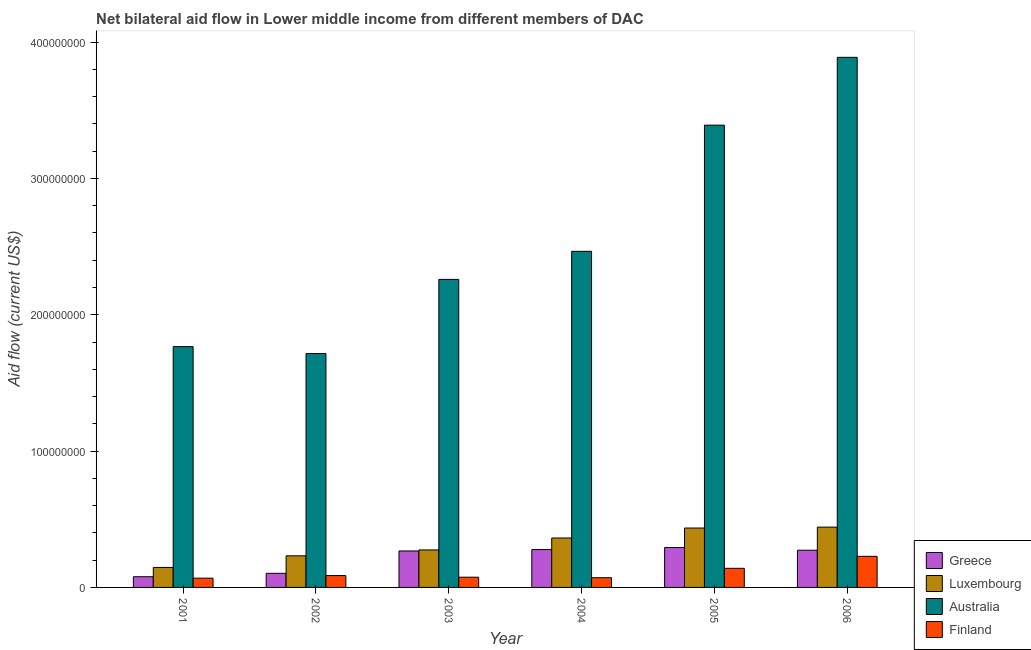How many different coloured bars are there?
Give a very brief answer. 4. How many groups of bars are there?
Your answer should be compact. 6. Are the number of bars on each tick of the X-axis equal?
Keep it short and to the point. Yes. What is the label of the 6th group of bars from the left?
Provide a succinct answer. 2006. What is the amount of aid given by luxembourg in 2002?
Your answer should be compact. 2.32e+07. Across all years, what is the maximum amount of aid given by australia?
Give a very brief answer. 3.89e+08. Across all years, what is the minimum amount of aid given by australia?
Ensure brevity in your answer.  1.72e+08. In which year was the amount of aid given by greece maximum?
Make the answer very short. 2005. What is the total amount of aid given by luxembourg in the graph?
Your response must be concise. 1.89e+08. What is the difference between the amount of aid given by australia in 2003 and that in 2004?
Your answer should be very brief. -2.06e+07. What is the difference between the amount of aid given by greece in 2004 and the amount of aid given by luxembourg in 2002?
Offer a very short reply. 1.74e+07. What is the average amount of aid given by finland per year?
Your answer should be compact. 1.12e+07. In the year 2005, what is the difference between the amount of aid given by finland and amount of aid given by greece?
Provide a short and direct response. 0. What is the ratio of the amount of aid given by luxembourg in 2004 to that in 2005?
Make the answer very short. 0.83. Is the amount of aid given by australia in 2002 less than that in 2004?
Provide a succinct answer. Yes. What is the difference between the highest and the second highest amount of aid given by luxembourg?
Your answer should be compact. 6.70e+05. What is the difference between the highest and the lowest amount of aid given by luxembourg?
Your response must be concise. 2.96e+07. In how many years, is the amount of aid given by luxembourg greater than the average amount of aid given by luxembourg taken over all years?
Your response must be concise. 3. Is the sum of the amount of aid given by finland in 2001 and 2004 greater than the maximum amount of aid given by greece across all years?
Your answer should be very brief. No. What does the 4th bar from the right in 2005 represents?
Provide a succinct answer. Greece. Are all the bars in the graph horizontal?
Provide a succinct answer. No. How many years are there in the graph?
Offer a terse response. 6. What is the difference between two consecutive major ticks on the Y-axis?
Your answer should be compact. 1.00e+08. Does the graph contain grids?
Ensure brevity in your answer.  No. What is the title of the graph?
Provide a short and direct response. Net bilateral aid flow in Lower middle income from different members of DAC. Does "Australia" appear as one of the legend labels in the graph?
Your answer should be very brief. Yes. What is the Aid flow (current US$) in Greece in 2001?
Offer a terse response. 7.85e+06. What is the Aid flow (current US$) in Luxembourg in 2001?
Offer a terse response. 1.47e+07. What is the Aid flow (current US$) in Australia in 2001?
Your answer should be compact. 1.77e+08. What is the Aid flow (current US$) in Finland in 2001?
Provide a succinct answer. 6.79e+06. What is the Aid flow (current US$) in Greece in 2002?
Provide a succinct answer. 1.04e+07. What is the Aid flow (current US$) in Luxembourg in 2002?
Your response must be concise. 2.32e+07. What is the Aid flow (current US$) in Australia in 2002?
Your answer should be very brief. 1.72e+08. What is the Aid flow (current US$) in Finland in 2002?
Keep it short and to the point. 8.70e+06. What is the Aid flow (current US$) in Greece in 2003?
Provide a succinct answer. 2.68e+07. What is the Aid flow (current US$) of Luxembourg in 2003?
Provide a short and direct response. 2.75e+07. What is the Aid flow (current US$) of Australia in 2003?
Offer a terse response. 2.26e+08. What is the Aid flow (current US$) in Finland in 2003?
Keep it short and to the point. 7.50e+06. What is the Aid flow (current US$) in Greece in 2004?
Ensure brevity in your answer.  2.78e+07. What is the Aid flow (current US$) of Luxembourg in 2004?
Your response must be concise. 3.63e+07. What is the Aid flow (current US$) in Australia in 2004?
Offer a terse response. 2.47e+08. What is the Aid flow (current US$) in Finland in 2004?
Provide a succinct answer. 7.13e+06. What is the Aid flow (current US$) of Greece in 2005?
Make the answer very short. 2.93e+07. What is the Aid flow (current US$) of Luxembourg in 2005?
Provide a short and direct response. 4.36e+07. What is the Aid flow (current US$) of Australia in 2005?
Make the answer very short. 3.39e+08. What is the Aid flow (current US$) of Finland in 2005?
Offer a very short reply. 1.40e+07. What is the Aid flow (current US$) of Greece in 2006?
Provide a short and direct response. 2.73e+07. What is the Aid flow (current US$) in Luxembourg in 2006?
Your answer should be compact. 4.42e+07. What is the Aid flow (current US$) in Australia in 2006?
Offer a terse response. 3.89e+08. What is the Aid flow (current US$) in Finland in 2006?
Provide a short and direct response. 2.28e+07. Across all years, what is the maximum Aid flow (current US$) in Greece?
Ensure brevity in your answer.  2.93e+07. Across all years, what is the maximum Aid flow (current US$) of Luxembourg?
Provide a short and direct response. 4.42e+07. Across all years, what is the maximum Aid flow (current US$) in Australia?
Make the answer very short. 3.89e+08. Across all years, what is the maximum Aid flow (current US$) in Finland?
Make the answer very short. 2.28e+07. Across all years, what is the minimum Aid flow (current US$) in Greece?
Your answer should be compact. 7.85e+06. Across all years, what is the minimum Aid flow (current US$) in Luxembourg?
Provide a succinct answer. 1.47e+07. Across all years, what is the minimum Aid flow (current US$) in Australia?
Ensure brevity in your answer.  1.72e+08. Across all years, what is the minimum Aid flow (current US$) in Finland?
Provide a short and direct response. 6.79e+06. What is the total Aid flow (current US$) of Greece in the graph?
Offer a very short reply. 1.29e+08. What is the total Aid flow (current US$) in Luxembourg in the graph?
Make the answer very short. 1.89e+08. What is the total Aid flow (current US$) in Australia in the graph?
Offer a terse response. 1.55e+09. What is the total Aid flow (current US$) of Finland in the graph?
Your answer should be very brief. 6.69e+07. What is the difference between the Aid flow (current US$) in Greece in 2001 and that in 2002?
Ensure brevity in your answer.  -2.50e+06. What is the difference between the Aid flow (current US$) in Luxembourg in 2001 and that in 2002?
Provide a short and direct response. -8.52e+06. What is the difference between the Aid flow (current US$) in Australia in 2001 and that in 2002?
Your answer should be very brief. 5.09e+06. What is the difference between the Aid flow (current US$) in Finland in 2001 and that in 2002?
Your answer should be very brief. -1.91e+06. What is the difference between the Aid flow (current US$) in Greece in 2001 and that in 2003?
Provide a short and direct response. -1.89e+07. What is the difference between the Aid flow (current US$) in Luxembourg in 2001 and that in 2003?
Offer a terse response. -1.28e+07. What is the difference between the Aid flow (current US$) of Australia in 2001 and that in 2003?
Ensure brevity in your answer.  -4.93e+07. What is the difference between the Aid flow (current US$) in Finland in 2001 and that in 2003?
Provide a short and direct response. -7.10e+05. What is the difference between the Aid flow (current US$) in Greece in 2001 and that in 2004?
Your response must be concise. -1.99e+07. What is the difference between the Aid flow (current US$) of Luxembourg in 2001 and that in 2004?
Provide a short and direct response. -2.16e+07. What is the difference between the Aid flow (current US$) of Australia in 2001 and that in 2004?
Your response must be concise. -6.99e+07. What is the difference between the Aid flow (current US$) in Finland in 2001 and that in 2004?
Keep it short and to the point. -3.40e+05. What is the difference between the Aid flow (current US$) of Greece in 2001 and that in 2005?
Make the answer very short. -2.14e+07. What is the difference between the Aid flow (current US$) of Luxembourg in 2001 and that in 2005?
Your answer should be very brief. -2.89e+07. What is the difference between the Aid flow (current US$) of Australia in 2001 and that in 2005?
Give a very brief answer. -1.62e+08. What is the difference between the Aid flow (current US$) of Finland in 2001 and that in 2005?
Offer a terse response. -7.22e+06. What is the difference between the Aid flow (current US$) in Greece in 2001 and that in 2006?
Your response must be concise. -1.94e+07. What is the difference between the Aid flow (current US$) of Luxembourg in 2001 and that in 2006?
Give a very brief answer. -2.96e+07. What is the difference between the Aid flow (current US$) in Australia in 2001 and that in 2006?
Your answer should be compact. -2.12e+08. What is the difference between the Aid flow (current US$) in Finland in 2001 and that in 2006?
Ensure brevity in your answer.  -1.60e+07. What is the difference between the Aid flow (current US$) of Greece in 2002 and that in 2003?
Offer a very short reply. -1.64e+07. What is the difference between the Aid flow (current US$) in Luxembourg in 2002 and that in 2003?
Your response must be concise. -4.33e+06. What is the difference between the Aid flow (current US$) in Australia in 2002 and that in 2003?
Offer a very short reply. -5.44e+07. What is the difference between the Aid flow (current US$) of Finland in 2002 and that in 2003?
Provide a short and direct response. 1.20e+06. What is the difference between the Aid flow (current US$) of Greece in 2002 and that in 2004?
Ensure brevity in your answer.  -1.74e+07. What is the difference between the Aid flow (current US$) of Luxembourg in 2002 and that in 2004?
Ensure brevity in your answer.  -1.31e+07. What is the difference between the Aid flow (current US$) in Australia in 2002 and that in 2004?
Provide a succinct answer. -7.50e+07. What is the difference between the Aid flow (current US$) in Finland in 2002 and that in 2004?
Give a very brief answer. 1.57e+06. What is the difference between the Aid flow (current US$) of Greece in 2002 and that in 2005?
Offer a terse response. -1.89e+07. What is the difference between the Aid flow (current US$) in Luxembourg in 2002 and that in 2005?
Provide a succinct answer. -2.04e+07. What is the difference between the Aid flow (current US$) in Australia in 2002 and that in 2005?
Provide a succinct answer. -1.68e+08. What is the difference between the Aid flow (current US$) of Finland in 2002 and that in 2005?
Your response must be concise. -5.31e+06. What is the difference between the Aid flow (current US$) in Greece in 2002 and that in 2006?
Make the answer very short. -1.69e+07. What is the difference between the Aid flow (current US$) of Luxembourg in 2002 and that in 2006?
Offer a terse response. -2.11e+07. What is the difference between the Aid flow (current US$) in Australia in 2002 and that in 2006?
Your answer should be very brief. -2.17e+08. What is the difference between the Aid flow (current US$) in Finland in 2002 and that in 2006?
Give a very brief answer. -1.41e+07. What is the difference between the Aid flow (current US$) in Greece in 2003 and that in 2004?
Provide a short and direct response. -1.03e+06. What is the difference between the Aid flow (current US$) in Luxembourg in 2003 and that in 2004?
Ensure brevity in your answer.  -8.75e+06. What is the difference between the Aid flow (current US$) of Australia in 2003 and that in 2004?
Provide a short and direct response. -2.06e+07. What is the difference between the Aid flow (current US$) of Finland in 2003 and that in 2004?
Your answer should be compact. 3.70e+05. What is the difference between the Aid flow (current US$) of Greece in 2003 and that in 2005?
Offer a very short reply. -2.51e+06. What is the difference between the Aid flow (current US$) of Luxembourg in 2003 and that in 2005?
Provide a succinct answer. -1.61e+07. What is the difference between the Aid flow (current US$) of Australia in 2003 and that in 2005?
Provide a short and direct response. -1.13e+08. What is the difference between the Aid flow (current US$) in Finland in 2003 and that in 2005?
Give a very brief answer. -6.51e+06. What is the difference between the Aid flow (current US$) of Greece in 2003 and that in 2006?
Your answer should be compact. -5.20e+05. What is the difference between the Aid flow (current US$) of Luxembourg in 2003 and that in 2006?
Provide a short and direct response. -1.67e+07. What is the difference between the Aid flow (current US$) of Australia in 2003 and that in 2006?
Keep it short and to the point. -1.63e+08. What is the difference between the Aid flow (current US$) of Finland in 2003 and that in 2006?
Ensure brevity in your answer.  -1.53e+07. What is the difference between the Aid flow (current US$) in Greece in 2004 and that in 2005?
Your answer should be compact. -1.48e+06. What is the difference between the Aid flow (current US$) in Luxembourg in 2004 and that in 2005?
Keep it short and to the point. -7.31e+06. What is the difference between the Aid flow (current US$) in Australia in 2004 and that in 2005?
Ensure brevity in your answer.  -9.26e+07. What is the difference between the Aid flow (current US$) of Finland in 2004 and that in 2005?
Provide a short and direct response. -6.88e+06. What is the difference between the Aid flow (current US$) of Greece in 2004 and that in 2006?
Your response must be concise. 5.10e+05. What is the difference between the Aid flow (current US$) of Luxembourg in 2004 and that in 2006?
Provide a short and direct response. -7.98e+06. What is the difference between the Aid flow (current US$) in Australia in 2004 and that in 2006?
Give a very brief answer. -1.42e+08. What is the difference between the Aid flow (current US$) in Finland in 2004 and that in 2006?
Offer a very short reply. -1.57e+07. What is the difference between the Aid flow (current US$) in Greece in 2005 and that in 2006?
Your answer should be very brief. 1.99e+06. What is the difference between the Aid flow (current US$) of Luxembourg in 2005 and that in 2006?
Offer a terse response. -6.70e+05. What is the difference between the Aid flow (current US$) of Australia in 2005 and that in 2006?
Your answer should be compact. -4.97e+07. What is the difference between the Aid flow (current US$) in Finland in 2005 and that in 2006?
Give a very brief answer. -8.80e+06. What is the difference between the Aid flow (current US$) of Greece in 2001 and the Aid flow (current US$) of Luxembourg in 2002?
Your answer should be very brief. -1.53e+07. What is the difference between the Aid flow (current US$) of Greece in 2001 and the Aid flow (current US$) of Australia in 2002?
Offer a terse response. -1.64e+08. What is the difference between the Aid flow (current US$) in Greece in 2001 and the Aid flow (current US$) in Finland in 2002?
Keep it short and to the point. -8.50e+05. What is the difference between the Aid flow (current US$) of Luxembourg in 2001 and the Aid flow (current US$) of Australia in 2002?
Make the answer very short. -1.57e+08. What is the difference between the Aid flow (current US$) in Luxembourg in 2001 and the Aid flow (current US$) in Finland in 2002?
Your response must be concise. 5.96e+06. What is the difference between the Aid flow (current US$) of Australia in 2001 and the Aid flow (current US$) of Finland in 2002?
Offer a very short reply. 1.68e+08. What is the difference between the Aid flow (current US$) in Greece in 2001 and the Aid flow (current US$) in Luxembourg in 2003?
Keep it short and to the point. -1.97e+07. What is the difference between the Aid flow (current US$) of Greece in 2001 and the Aid flow (current US$) of Australia in 2003?
Ensure brevity in your answer.  -2.18e+08. What is the difference between the Aid flow (current US$) of Luxembourg in 2001 and the Aid flow (current US$) of Australia in 2003?
Ensure brevity in your answer.  -2.11e+08. What is the difference between the Aid flow (current US$) in Luxembourg in 2001 and the Aid flow (current US$) in Finland in 2003?
Your answer should be compact. 7.16e+06. What is the difference between the Aid flow (current US$) in Australia in 2001 and the Aid flow (current US$) in Finland in 2003?
Your answer should be very brief. 1.69e+08. What is the difference between the Aid flow (current US$) in Greece in 2001 and the Aid flow (current US$) in Luxembourg in 2004?
Ensure brevity in your answer.  -2.84e+07. What is the difference between the Aid flow (current US$) of Greece in 2001 and the Aid flow (current US$) of Australia in 2004?
Your answer should be very brief. -2.39e+08. What is the difference between the Aid flow (current US$) of Greece in 2001 and the Aid flow (current US$) of Finland in 2004?
Your answer should be compact. 7.20e+05. What is the difference between the Aid flow (current US$) in Luxembourg in 2001 and the Aid flow (current US$) in Australia in 2004?
Your answer should be compact. -2.32e+08. What is the difference between the Aid flow (current US$) in Luxembourg in 2001 and the Aid flow (current US$) in Finland in 2004?
Your answer should be very brief. 7.53e+06. What is the difference between the Aid flow (current US$) of Australia in 2001 and the Aid flow (current US$) of Finland in 2004?
Offer a very short reply. 1.70e+08. What is the difference between the Aid flow (current US$) in Greece in 2001 and the Aid flow (current US$) in Luxembourg in 2005?
Make the answer very short. -3.57e+07. What is the difference between the Aid flow (current US$) of Greece in 2001 and the Aid flow (current US$) of Australia in 2005?
Keep it short and to the point. -3.31e+08. What is the difference between the Aid flow (current US$) in Greece in 2001 and the Aid flow (current US$) in Finland in 2005?
Offer a very short reply. -6.16e+06. What is the difference between the Aid flow (current US$) of Luxembourg in 2001 and the Aid flow (current US$) of Australia in 2005?
Provide a short and direct response. -3.24e+08. What is the difference between the Aid flow (current US$) in Luxembourg in 2001 and the Aid flow (current US$) in Finland in 2005?
Your answer should be very brief. 6.50e+05. What is the difference between the Aid flow (current US$) of Australia in 2001 and the Aid flow (current US$) of Finland in 2005?
Make the answer very short. 1.63e+08. What is the difference between the Aid flow (current US$) of Greece in 2001 and the Aid flow (current US$) of Luxembourg in 2006?
Make the answer very short. -3.64e+07. What is the difference between the Aid flow (current US$) of Greece in 2001 and the Aid flow (current US$) of Australia in 2006?
Keep it short and to the point. -3.81e+08. What is the difference between the Aid flow (current US$) in Greece in 2001 and the Aid flow (current US$) in Finland in 2006?
Offer a terse response. -1.50e+07. What is the difference between the Aid flow (current US$) in Luxembourg in 2001 and the Aid flow (current US$) in Australia in 2006?
Offer a very short reply. -3.74e+08. What is the difference between the Aid flow (current US$) of Luxembourg in 2001 and the Aid flow (current US$) of Finland in 2006?
Ensure brevity in your answer.  -8.15e+06. What is the difference between the Aid flow (current US$) in Australia in 2001 and the Aid flow (current US$) in Finland in 2006?
Make the answer very short. 1.54e+08. What is the difference between the Aid flow (current US$) in Greece in 2002 and the Aid flow (current US$) in Luxembourg in 2003?
Ensure brevity in your answer.  -1.72e+07. What is the difference between the Aid flow (current US$) of Greece in 2002 and the Aid flow (current US$) of Australia in 2003?
Make the answer very short. -2.16e+08. What is the difference between the Aid flow (current US$) of Greece in 2002 and the Aid flow (current US$) of Finland in 2003?
Your response must be concise. 2.85e+06. What is the difference between the Aid flow (current US$) of Luxembourg in 2002 and the Aid flow (current US$) of Australia in 2003?
Make the answer very short. -2.03e+08. What is the difference between the Aid flow (current US$) in Luxembourg in 2002 and the Aid flow (current US$) in Finland in 2003?
Your answer should be very brief. 1.57e+07. What is the difference between the Aid flow (current US$) of Australia in 2002 and the Aid flow (current US$) of Finland in 2003?
Your response must be concise. 1.64e+08. What is the difference between the Aid flow (current US$) in Greece in 2002 and the Aid flow (current US$) in Luxembourg in 2004?
Your response must be concise. -2.59e+07. What is the difference between the Aid flow (current US$) of Greece in 2002 and the Aid flow (current US$) of Australia in 2004?
Your answer should be compact. -2.36e+08. What is the difference between the Aid flow (current US$) of Greece in 2002 and the Aid flow (current US$) of Finland in 2004?
Keep it short and to the point. 3.22e+06. What is the difference between the Aid flow (current US$) in Luxembourg in 2002 and the Aid flow (current US$) in Australia in 2004?
Provide a short and direct response. -2.23e+08. What is the difference between the Aid flow (current US$) in Luxembourg in 2002 and the Aid flow (current US$) in Finland in 2004?
Ensure brevity in your answer.  1.60e+07. What is the difference between the Aid flow (current US$) in Australia in 2002 and the Aid flow (current US$) in Finland in 2004?
Ensure brevity in your answer.  1.64e+08. What is the difference between the Aid flow (current US$) in Greece in 2002 and the Aid flow (current US$) in Luxembourg in 2005?
Provide a succinct answer. -3.32e+07. What is the difference between the Aid flow (current US$) in Greece in 2002 and the Aid flow (current US$) in Australia in 2005?
Provide a short and direct response. -3.29e+08. What is the difference between the Aid flow (current US$) of Greece in 2002 and the Aid flow (current US$) of Finland in 2005?
Make the answer very short. -3.66e+06. What is the difference between the Aid flow (current US$) of Luxembourg in 2002 and the Aid flow (current US$) of Australia in 2005?
Give a very brief answer. -3.16e+08. What is the difference between the Aid flow (current US$) of Luxembourg in 2002 and the Aid flow (current US$) of Finland in 2005?
Keep it short and to the point. 9.17e+06. What is the difference between the Aid flow (current US$) in Australia in 2002 and the Aid flow (current US$) in Finland in 2005?
Ensure brevity in your answer.  1.58e+08. What is the difference between the Aid flow (current US$) of Greece in 2002 and the Aid flow (current US$) of Luxembourg in 2006?
Offer a terse response. -3.39e+07. What is the difference between the Aid flow (current US$) of Greece in 2002 and the Aid flow (current US$) of Australia in 2006?
Make the answer very short. -3.78e+08. What is the difference between the Aid flow (current US$) in Greece in 2002 and the Aid flow (current US$) in Finland in 2006?
Your response must be concise. -1.25e+07. What is the difference between the Aid flow (current US$) in Luxembourg in 2002 and the Aid flow (current US$) in Australia in 2006?
Offer a very short reply. -3.66e+08. What is the difference between the Aid flow (current US$) in Luxembourg in 2002 and the Aid flow (current US$) in Finland in 2006?
Offer a terse response. 3.70e+05. What is the difference between the Aid flow (current US$) in Australia in 2002 and the Aid flow (current US$) in Finland in 2006?
Your answer should be compact. 1.49e+08. What is the difference between the Aid flow (current US$) of Greece in 2003 and the Aid flow (current US$) of Luxembourg in 2004?
Keep it short and to the point. -9.51e+06. What is the difference between the Aid flow (current US$) of Greece in 2003 and the Aid flow (current US$) of Australia in 2004?
Offer a terse response. -2.20e+08. What is the difference between the Aid flow (current US$) of Greece in 2003 and the Aid flow (current US$) of Finland in 2004?
Make the answer very short. 1.96e+07. What is the difference between the Aid flow (current US$) in Luxembourg in 2003 and the Aid flow (current US$) in Australia in 2004?
Offer a terse response. -2.19e+08. What is the difference between the Aid flow (current US$) in Luxembourg in 2003 and the Aid flow (current US$) in Finland in 2004?
Your answer should be very brief. 2.04e+07. What is the difference between the Aid flow (current US$) of Australia in 2003 and the Aid flow (current US$) of Finland in 2004?
Provide a short and direct response. 2.19e+08. What is the difference between the Aid flow (current US$) in Greece in 2003 and the Aid flow (current US$) in Luxembourg in 2005?
Make the answer very short. -1.68e+07. What is the difference between the Aid flow (current US$) in Greece in 2003 and the Aid flow (current US$) in Australia in 2005?
Your answer should be very brief. -3.12e+08. What is the difference between the Aid flow (current US$) in Greece in 2003 and the Aid flow (current US$) in Finland in 2005?
Ensure brevity in your answer.  1.27e+07. What is the difference between the Aid flow (current US$) in Luxembourg in 2003 and the Aid flow (current US$) in Australia in 2005?
Provide a succinct answer. -3.12e+08. What is the difference between the Aid flow (current US$) of Luxembourg in 2003 and the Aid flow (current US$) of Finland in 2005?
Keep it short and to the point. 1.35e+07. What is the difference between the Aid flow (current US$) of Australia in 2003 and the Aid flow (current US$) of Finland in 2005?
Your response must be concise. 2.12e+08. What is the difference between the Aid flow (current US$) in Greece in 2003 and the Aid flow (current US$) in Luxembourg in 2006?
Offer a very short reply. -1.75e+07. What is the difference between the Aid flow (current US$) of Greece in 2003 and the Aid flow (current US$) of Australia in 2006?
Give a very brief answer. -3.62e+08. What is the difference between the Aid flow (current US$) in Greece in 2003 and the Aid flow (current US$) in Finland in 2006?
Ensure brevity in your answer.  3.94e+06. What is the difference between the Aid flow (current US$) in Luxembourg in 2003 and the Aid flow (current US$) in Australia in 2006?
Keep it short and to the point. -3.61e+08. What is the difference between the Aid flow (current US$) of Luxembourg in 2003 and the Aid flow (current US$) of Finland in 2006?
Keep it short and to the point. 4.70e+06. What is the difference between the Aid flow (current US$) in Australia in 2003 and the Aid flow (current US$) in Finland in 2006?
Your response must be concise. 2.03e+08. What is the difference between the Aid flow (current US$) in Greece in 2004 and the Aid flow (current US$) in Luxembourg in 2005?
Your response must be concise. -1.58e+07. What is the difference between the Aid flow (current US$) of Greece in 2004 and the Aid flow (current US$) of Australia in 2005?
Give a very brief answer. -3.11e+08. What is the difference between the Aid flow (current US$) of Greece in 2004 and the Aid flow (current US$) of Finland in 2005?
Offer a very short reply. 1.38e+07. What is the difference between the Aid flow (current US$) of Luxembourg in 2004 and the Aid flow (current US$) of Australia in 2005?
Offer a very short reply. -3.03e+08. What is the difference between the Aid flow (current US$) in Luxembourg in 2004 and the Aid flow (current US$) in Finland in 2005?
Offer a terse response. 2.22e+07. What is the difference between the Aid flow (current US$) in Australia in 2004 and the Aid flow (current US$) in Finland in 2005?
Offer a terse response. 2.33e+08. What is the difference between the Aid flow (current US$) in Greece in 2004 and the Aid flow (current US$) in Luxembourg in 2006?
Your answer should be very brief. -1.65e+07. What is the difference between the Aid flow (current US$) of Greece in 2004 and the Aid flow (current US$) of Australia in 2006?
Give a very brief answer. -3.61e+08. What is the difference between the Aid flow (current US$) in Greece in 2004 and the Aid flow (current US$) in Finland in 2006?
Ensure brevity in your answer.  4.97e+06. What is the difference between the Aid flow (current US$) in Luxembourg in 2004 and the Aid flow (current US$) in Australia in 2006?
Give a very brief answer. -3.53e+08. What is the difference between the Aid flow (current US$) of Luxembourg in 2004 and the Aid flow (current US$) of Finland in 2006?
Give a very brief answer. 1.34e+07. What is the difference between the Aid flow (current US$) of Australia in 2004 and the Aid flow (current US$) of Finland in 2006?
Your answer should be very brief. 2.24e+08. What is the difference between the Aid flow (current US$) of Greece in 2005 and the Aid flow (current US$) of Luxembourg in 2006?
Ensure brevity in your answer.  -1.50e+07. What is the difference between the Aid flow (current US$) in Greece in 2005 and the Aid flow (current US$) in Australia in 2006?
Provide a short and direct response. -3.60e+08. What is the difference between the Aid flow (current US$) in Greece in 2005 and the Aid flow (current US$) in Finland in 2006?
Provide a succinct answer. 6.45e+06. What is the difference between the Aid flow (current US$) of Luxembourg in 2005 and the Aid flow (current US$) of Australia in 2006?
Your answer should be compact. -3.45e+08. What is the difference between the Aid flow (current US$) of Luxembourg in 2005 and the Aid flow (current US$) of Finland in 2006?
Your answer should be compact. 2.08e+07. What is the difference between the Aid flow (current US$) of Australia in 2005 and the Aid flow (current US$) of Finland in 2006?
Your answer should be very brief. 3.16e+08. What is the average Aid flow (current US$) of Greece per year?
Provide a short and direct response. 2.15e+07. What is the average Aid flow (current US$) of Luxembourg per year?
Provide a short and direct response. 3.16e+07. What is the average Aid flow (current US$) of Australia per year?
Give a very brief answer. 2.58e+08. What is the average Aid flow (current US$) of Finland per year?
Ensure brevity in your answer.  1.12e+07. In the year 2001, what is the difference between the Aid flow (current US$) in Greece and Aid flow (current US$) in Luxembourg?
Ensure brevity in your answer.  -6.81e+06. In the year 2001, what is the difference between the Aid flow (current US$) in Greece and Aid flow (current US$) in Australia?
Make the answer very short. -1.69e+08. In the year 2001, what is the difference between the Aid flow (current US$) of Greece and Aid flow (current US$) of Finland?
Your answer should be very brief. 1.06e+06. In the year 2001, what is the difference between the Aid flow (current US$) in Luxembourg and Aid flow (current US$) in Australia?
Give a very brief answer. -1.62e+08. In the year 2001, what is the difference between the Aid flow (current US$) of Luxembourg and Aid flow (current US$) of Finland?
Make the answer very short. 7.87e+06. In the year 2001, what is the difference between the Aid flow (current US$) of Australia and Aid flow (current US$) of Finland?
Make the answer very short. 1.70e+08. In the year 2002, what is the difference between the Aid flow (current US$) of Greece and Aid flow (current US$) of Luxembourg?
Offer a very short reply. -1.28e+07. In the year 2002, what is the difference between the Aid flow (current US$) in Greece and Aid flow (current US$) in Australia?
Ensure brevity in your answer.  -1.61e+08. In the year 2002, what is the difference between the Aid flow (current US$) of Greece and Aid flow (current US$) of Finland?
Provide a short and direct response. 1.65e+06. In the year 2002, what is the difference between the Aid flow (current US$) in Luxembourg and Aid flow (current US$) in Australia?
Provide a succinct answer. -1.48e+08. In the year 2002, what is the difference between the Aid flow (current US$) of Luxembourg and Aid flow (current US$) of Finland?
Give a very brief answer. 1.45e+07. In the year 2002, what is the difference between the Aid flow (current US$) in Australia and Aid flow (current US$) in Finland?
Make the answer very short. 1.63e+08. In the year 2003, what is the difference between the Aid flow (current US$) in Greece and Aid flow (current US$) in Luxembourg?
Offer a terse response. -7.60e+05. In the year 2003, what is the difference between the Aid flow (current US$) in Greece and Aid flow (current US$) in Australia?
Keep it short and to the point. -1.99e+08. In the year 2003, what is the difference between the Aid flow (current US$) of Greece and Aid flow (current US$) of Finland?
Offer a terse response. 1.92e+07. In the year 2003, what is the difference between the Aid flow (current US$) in Luxembourg and Aid flow (current US$) in Australia?
Your answer should be compact. -1.98e+08. In the year 2003, what is the difference between the Aid flow (current US$) in Luxembourg and Aid flow (current US$) in Finland?
Provide a succinct answer. 2.00e+07. In the year 2003, what is the difference between the Aid flow (current US$) in Australia and Aid flow (current US$) in Finland?
Give a very brief answer. 2.18e+08. In the year 2004, what is the difference between the Aid flow (current US$) in Greece and Aid flow (current US$) in Luxembourg?
Provide a succinct answer. -8.48e+06. In the year 2004, what is the difference between the Aid flow (current US$) in Greece and Aid flow (current US$) in Australia?
Give a very brief answer. -2.19e+08. In the year 2004, what is the difference between the Aid flow (current US$) of Greece and Aid flow (current US$) of Finland?
Offer a very short reply. 2.06e+07. In the year 2004, what is the difference between the Aid flow (current US$) in Luxembourg and Aid flow (current US$) in Australia?
Provide a succinct answer. -2.10e+08. In the year 2004, what is the difference between the Aid flow (current US$) of Luxembourg and Aid flow (current US$) of Finland?
Give a very brief answer. 2.91e+07. In the year 2004, what is the difference between the Aid flow (current US$) in Australia and Aid flow (current US$) in Finland?
Offer a terse response. 2.39e+08. In the year 2005, what is the difference between the Aid flow (current US$) of Greece and Aid flow (current US$) of Luxembourg?
Offer a terse response. -1.43e+07. In the year 2005, what is the difference between the Aid flow (current US$) in Greece and Aid flow (current US$) in Australia?
Keep it short and to the point. -3.10e+08. In the year 2005, what is the difference between the Aid flow (current US$) of Greece and Aid flow (current US$) of Finland?
Keep it short and to the point. 1.52e+07. In the year 2005, what is the difference between the Aid flow (current US$) of Luxembourg and Aid flow (current US$) of Australia?
Make the answer very short. -2.96e+08. In the year 2005, what is the difference between the Aid flow (current US$) of Luxembourg and Aid flow (current US$) of Finland?
Give a very brief answer. 2.96e+07. In the year 2005, what is the difference between the Aid flow (current US$) of Australia and Aid flow (current US$) of Finland?
Provide a short and direct response. 3.25e+08. In the year 2006, what is the difference between the Aid flow (current US$) of Greece and Aid flow (current US$) of Luxembourg?
Give a very brief answer. -1.70e+07. In the year 2006, what is the difference between the Aid flow (current US$) in Greece and Aid flow (current US$) in Australia?
Provide a short and direct response. -3.62e+08. In the year 2006, what is the difference between the Aid flow (current US$) of Greece and Aid flow (current US$) of Finland?
Your answer should be compact. 4.46e+06. In the year 2006, what is the difference between the Aid flow (current US$) in Luxembourg and Aid flow (current US$) in Australia?
Your answer should be very brief. -3.45e+08. In the year 2006, what is the difference between the Aid flow (current US$) of Luxembourg and Aid flow (current US$) of Finland?
Your answer should be very brief. 2.14e+07. In the year 2006, what is the difference between the Aid flow (current US$) of Australia and Aid flow (current US$) of Finland?
Offer a terse response. 3.66e+08. What is the ratio of the Aid flow (current US$) of Greece in 2001 to that in 2002?
Provide a succinct answer. 0.76. What is the ratio of the Aid flow (current US$) of Luxembourg in 2001 to that in 2002?
Give a very brief answer. 0.63. What is the ratio of the Aid flow (current US$) of Australia in 2001 to that in 2002?
Give a very brief answer. 1.03. What is the ratio of the Aid flow (current US$) of Finland in 2001 to that in 2002?
Keep it short and to the point. 0.78. What is the ratio of the Aid flow (current US$) of Greece in 2001 to that in 2003?
Keep it short and to the point. 0.29. What is the ratio of the Aid flow (current US$) in Luxembourg in 2001 to that in 2003?
Make the answer very short. 0.53. What is the ratio of the Aid flow (current US$) in Australia in 2001 to that in 2003?
Make the answer very short. 0.78. What is the ratio of the Aid flow (current US$) of Finland in 2001 to that in 2003?
Give a very brief answer. 0.91. What is the ratio of the Aid flow (current US$) in Greece in 2001 to that in 2004?
Your answer should be compact. 0.28. What is the ratio of the Aid flow (current US$) of Luxembourg in 2001 to that in 2004?
Keep it short and to the point. 0.4. What is the ratio of the Aid flow (current US$) of Australia in 2001 to that in 2004?
Offer a terse response. 0.72. What is the ratio of the Aid flow (current US$) of Finland in 2001 to that in 2004?
Keep it short and to the point. 0.95. What is the ratio of the Aid flow (current US$) in Greece in 2001 to that in 2005?
Offer a very short reply. 0.27. What is the ratio of the Aid flow (current US$) of Luxembourg in 2001 to that in 2005?
Ensure brevity in your answer.  0.34. What is the ratio of the Aid flow (current US$) in Australia in 2001 to that in 2005?
Your response must be concise. 0.52. What is the ratio of the Aid flow (current US$) in Finland in 2001 to that in 2005?
Offer a very short reply. 0.48. What is the ratio of the Aid flow (current US$) of Greece in 2001 to that in 2006?
Make the answer very short. 0.29. What is the ratio of the Aid flow (current US$) in Luxembourg in 2001 to that in 2006?
Ensure brevity in your answer.  0.33. What is the ratio of the Aid flow (current US$) of Australia in 2001 to that in 2006?
Provide a short and direct response. 0.45. What is the ratio of the Aid flow (current US$) in Finland in 2001 to that in 2006?
Provide a short and direct response. 0.3. What is the ratio of the Aid flow (current US$) of Greece in 2002 to that in 2003?
Provide a short and direct response. 0.39. What is the ratio of the Aid flow (current US$) in Luxembourg in 2002 to that in 2003?
Give a very brief answer. 0.84. What is the ratio of the Aid flow (current US$) of Australia in 2002 to that in 2003?
Make the answer very short. 0.76. What is the ratio of the Aid flow (current US$) in Finland in 2002 to that in 2003?
Make the answer very short. 1.16. What is the ratio of the Aid flow (current US$) in Greece in 2002 to that in 2004?
Ensure brevity in your answer.  0.37. What is the ratio of the Aid flow (current US$) in Luxembourg in 2002 to that in 2004?
Ensure brevity in your answer.  0.64. What is the ratio of the Aid flow (current US$) in Australia in 2002 to that in 2004?
Your answer should be compact. 0.7. What is the ratio of the Aid flow (current US$) of Finland in 2002 to that in 2004?
Ensure brevity in your answer.  1.22. What is the ratio of the Aid flow (current US$) in Greece in 2002 to that in 2005?
Your answer should be compact. 0.35. What is the ratio of the Aid flow (current US$) of Luxembourg in 2002 to that in 2005?
Your response must be concise. 0.53. What is the ratio of the Aid flow (current US$) of Australia in 2002 to that in 2005?
Give a very brief answer. 0.51. What is the ratio of the Aid flow (current US$) in Finland in 2002 to that in 2005?
Offer a very short reply. 0.62. What is the ratio of the Aid flow (current US$) in Greece in 2002 to that in 2006?
Offer a terse response. 0.38. What is the ratio of the Aid flow (current US$) in Luxembourg in 2002 to that in 2006?
Provide a succinct answer. 0.52. What is the ratio of the Aid flow (current US$) of Australia in 2002 to that in 2006?
Give a very brief answer. 0.44. What is the ratio of the Aid flow (current US$) of Finland in 2002 to that in 2006?
Provide a short and direct response. 0.38. What is the ratio of the Aid flow (current US$) of Greece in 2003 to that in 2004?
Make the answer very short. 0.96. What is the ratio of the Aid flow (current US$) of Luxembourg in 2003 to that in 2004?
Provide a succinct answer. 0.76. What is the ratio of the Aid flow (current US$) of Australia in 2003 to that in 2004?
Provide a succinct answer. 0.92. What is the ratio of the Aid flow (current US$) in Finland in 2003 to that in 2004?
Your answer should be very brief. 1.05. What is the ratio of the Aid flow (current US$) of Greece in 2003 to that in 2005?
Ensure brevity in your answer.  0.91. What is the ratio of the Aid flow (current US$) in Luxembourg in 2003 to that in 2005?
Make the answer very short. 0.63. What is the ratio of the Aid flow (current US$) of Australia in 2003 to that in 2005?
Make the answer very short. 0.67. What is the ratio of the Aid flow (current US$) of Finland in 2003 to that in 2005?
Offer a terse response. 0.54. What is the ratio of the Aid flow (current US$) of Greece in 2003 to that in 2006?
Your answer should be compact. 0.98. What is the ratio of the Aid flow (current US$) of Luxembourg in 2003 to that in 2006?
Your answer should be very brief. 0.62. What is the ratio of the Aid flow (current US$) in Australia in 2003 to that in 2006?
Ensure brevity in your answer.  0.58. What is the ratio of the Aid flow (current US$) of Finland in 2003 to that in 2006?
Your response must be concise. 0.33. What is the ratio of the Aid flow (current US$) of Greece in 2004 to that in 2005?
Make the answer very short. 0.95. What is the ratio of the Aid flow (current US$) of Luxembourg in 2004 to that in 2005?
Your answer should be compact. 0.83. What is the ratio of the Aid flow (current US$) of Australia in 2004 to that in 2005?
Give a very brief answer. 0.73. What is the ratio of the Aid flow (current US$) in Finland in 2004 to that in 2005?
Your answer should be very brief. 0.51. What is the ratio of the Aid flow (current US$) of Greece in 2004 to that in 2006?
Offer a very short reply. 1.02. What is the ratio of the Aid flow (current US$) of Luxembourg in 2004 to that in 2006?
Ensure brevity in your answer.  0.82. What is the ratio of the Aid flow (current US$) in Australia in 2004 to that in 2006?
Provide a succinct answer. 0.63. What is the ratio of the Aid flow (current US$) of Finland in 2004 to that in 2006?
Offer a terse response. 0.31. What is the ratio of the Aid flow (current US$) of Greece in 2005 to that in 2006?
Make the answer very short. 1.07. What is the ratio of the Aid flow (current US$) in Luxembourg in 2005 to that in 2006?
Make the answer very short. 0.98. What is the ratio of the Aid flow (current US$) of Australia in 2005 to that in 2006?
Keep it short and to the point. 0.87. What is the ratio of the Aid flow (current US$) of Finland in 2005 to that in 2006?
Give a very brief answer. 0.61. What is the difference between the highest and the second highest Aid flow (current US$) of Greece?
Keep it short and to the point. 1.48e+06. What is the difference between the highest and the second highest Aid flow (current US$) of Luxembourg?
Make the answer very short. 6.70e+05. What is the difference between the highest and the second highest Aid flow (current US$) of Australia?
Provide a succinct answer. 4.97e+07. What is the difference between the highest and the second highest Aid flow (current US$) of Finland?
Provide a succinct answer. 8.80e+06. What is the difference between the highest and the lowest Aid flow (current US$) in Greece?
Your answer should be very brief. 2.14e+07. What is the difference between the highest and the lowest Aid flow (current US$) of Luxembourg?
Offer a terse response. 2.96e+07. What is the difference between the highest and the lowest Aid flow (current US$) of Australia?
Make the answer very short. 2.17e+08. What is the difference between the highest and the lowest Aid flow (current US$) in Finland?
Provide a succinct answer. 1.60e+07. 